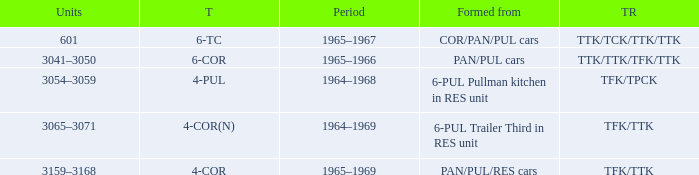Name the trailers for formed from pan/pul/res cars TFK/TTK. 